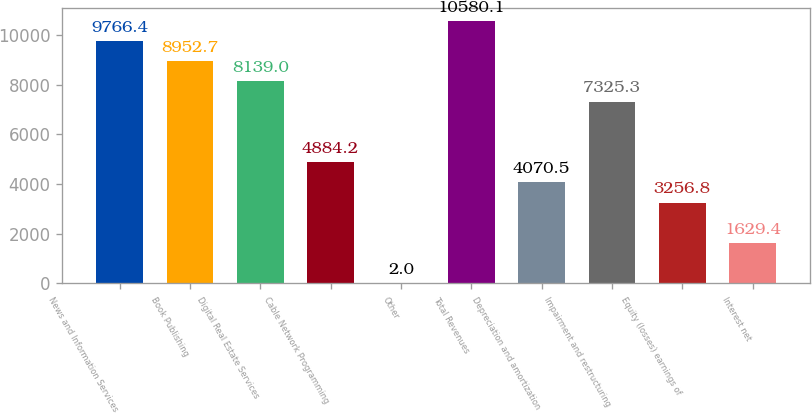Convert chart to OTSL. <chart><loc_0><loc_0><loc_500><loc_500><bar_chart><fcel>News and Information Services<fcel>Book Publishing<fcel>Digital Real Estate Services<fcel>Cable Network Programming<fcel>Other<fcel>Total Revenues<fcel>Depreciation and amortization<fcel>Impairment and restructuring<fcel>Equity (losses) earnings of<fcel>Interest net<nl><fcel>9766.4<fcel>8952.7<fcel>8139<fcel>4884.2<fcel>2<fcel>10580.1<fcel>4070.5<fcel>7325.3<fcel>3256.8<fcel>1629.4<nl></chart> 